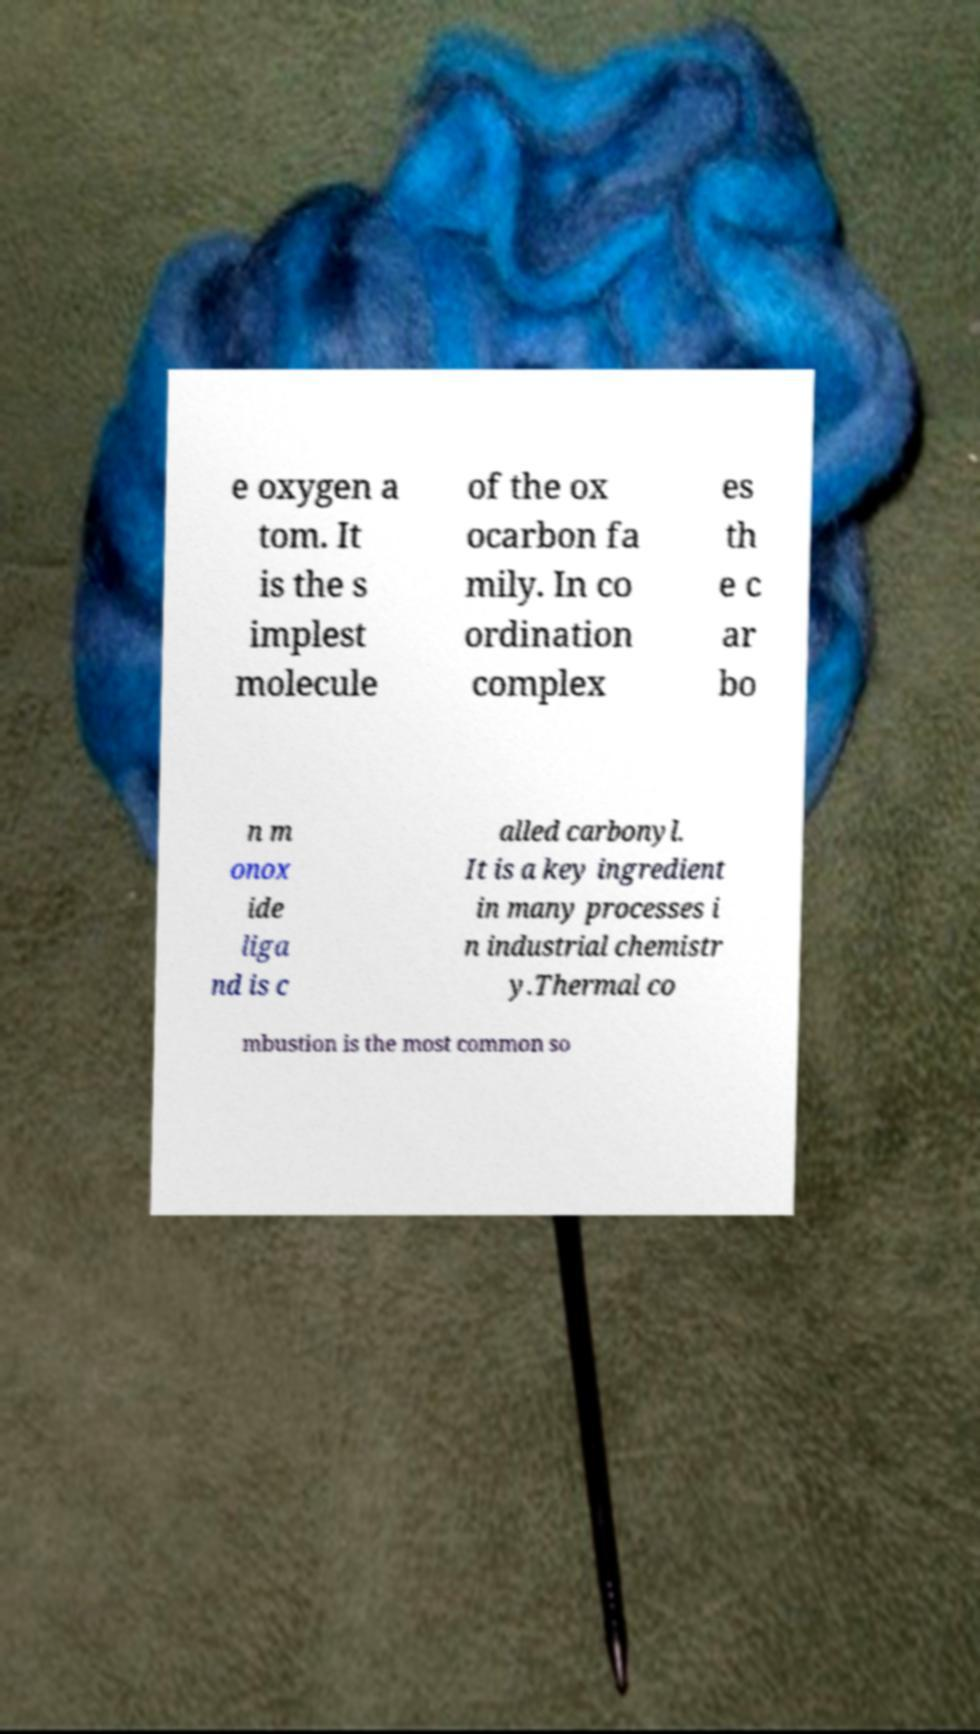For documentation purposes, I need the text within this image transcribed. Could you provide that? e oxygen a tom. It is the s implest molecule of the ox ocarbon fa mily. In co ordination complex es th e c ar bo n m onox ide liga nd is c alled carbonyl. It is a key ingredient in many processes i n industrial chemistr y.Thermal co mbustion is the most common so 